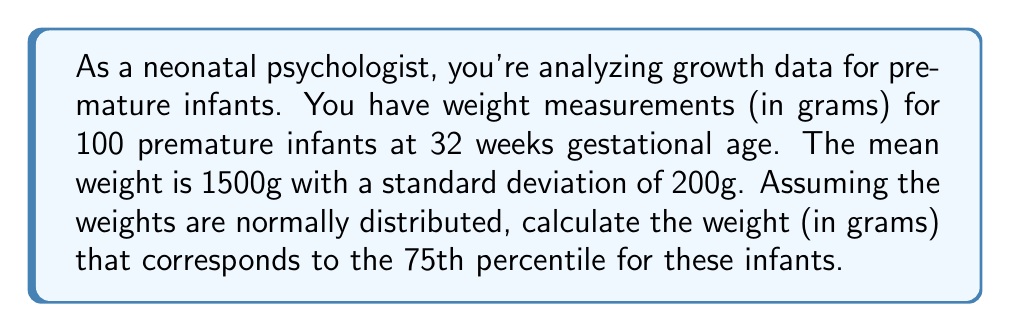Show me your answer to this math problem. To solve this problem, we'll use the properties of the normal distribution and the z-score formula. Here's a step-by-step approach:

1) In a normal distribution, percentiles correspond to specific z-scores. The 75th percentile corresponds to a z-score of 0.674.

2) We know:
   - Mean (μ) = 1500g
   - Standard deviation (σ) = 200g
   - Z-score for 75th percentile = 0.674

3) The z-score formula is:

   $$ z = \frac{x - \mu}{\sigma} $$

   Where x is the value we're looking for (the 75th percentile weight).

4) Rearranging the formula to solve for x:

   $$ x = \mu + z\sigma $$

5) Plugging in our known values:

   $$ x = 1500 + (0.674 * 200) $$

6) Calculating:

   $$ x = 1500 + 134.8 = 1634.8 $$

7) Rounding to the nearest gram:

   $$ x \approx 1635 \text{ grams} $$

Therefore, the weight at the 75th percentile is approximately 1635 grams.
Answer: 1635 grams 